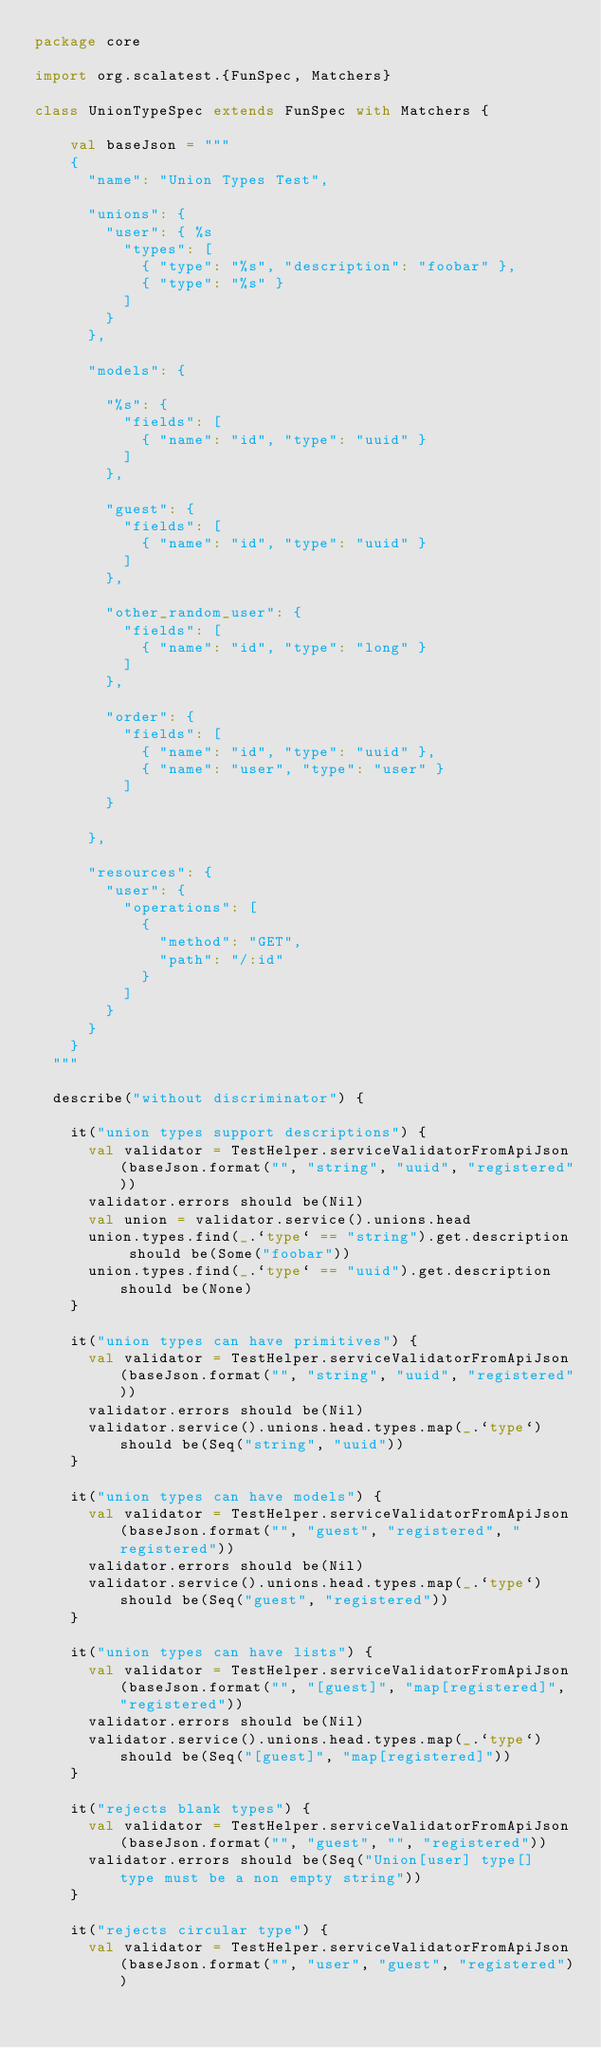Convert code to text. <code><loc_0><loc_0><loc_500><loc_500><_Scala_>package core

import org.scalatest.{FunSpec, Matchers}

class UnionTypeSpec extends FunSpec with Matchers {

    val baseJson = """
    {
      "name": "Union Types Test",

      "unions": {
        "user": { %s
          "types": [
            { "type": "%s", "description": "foobar" },
            { "type": "%s" }
          ]
        }
      },

      "models": {

        "%s": {
          "fields": [
            { "name": "id", "type": "uuid" }
          ]
        },

        "guest": {
          "fields": [
            { "name": "id", "type": "uuid" }
          ]
        },

        "other_random_user": {
          "fields": [
            { "name": "id", "type": "long" }
          ]
        },

        "order": {
          "fields": [
            { "name": "id", "type": "uuid" },
            { "name": "user", "type": "user" }
          ]
        }

      },

      "resources": {
        "user": {
          "operations": [
            {
              "method": "GET",
              "path": "/:id"
            }
          ]
        }
      }
    }
  """

  describe("without discriminator") {

    it("union types support descriptions") {
      val validator = TestHelper.serviceValidatorFromApiJson(baseJson.format("", "string", "uuid", "registered"))
      validator.errors should be(Nil)
      val union = validator.service().unions.head
      union.types.find(_.`type` == "string").get.description should be(Some("foobar"))
      union.types.find(_.`type` == "uuid").get.description should be(None)
    }

    it("union types can have primitives") {
      val validator = TestHelper.serviceValidatorFromApiJson(baseJson.format("", "string", "uuid", "registered"))
      validator.errors should be(Nil)
      validator.service().unions.head.types.map(_.`type`) should be(Seq("string", "uuid"))
    }

    it("union types can have models") {
      val validator = TestHelper.serviceValidatorFromApiJson(baseJson.format("", "guest", "registered", "registered"))
      validator.errors should be(Nil)
      validator.service().unions.head.types.map(_.`type`) should be(Seq("guest", "registered"))
    }

    it("union types can have lists") {
      val validator = TestHelper.serviceValidatorFromApiJson(baseJson.format("", "[guest]", "map[registered]", "registered"))
      validator.errors should be(Nil)
      validator.service().unions.head.types.map(_.`type`) should be(Seq("[guest]", "map[registered]"))
    }

    it("rejects blank types") {
      val validator = TestHelper.serviceValidatorFromApiJson(baseJson.format("", "guest", "", "registered"))
      validator.errors should be(Seq("Union[user] type[] type must be a non empty string"))
    }

    it("rejects circular type") {
      val validator = TestHelper.serviceValidatorFromApiJson(baseJson.format("", "user", "guest", "registered"))</code> 